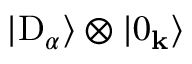Convert formula to latex. <formula><loc_0><loc_0><loc_500><loc_500>| D _ { \alpha } \rangle \otimes | 0 _ { k } \rangle</formula> 